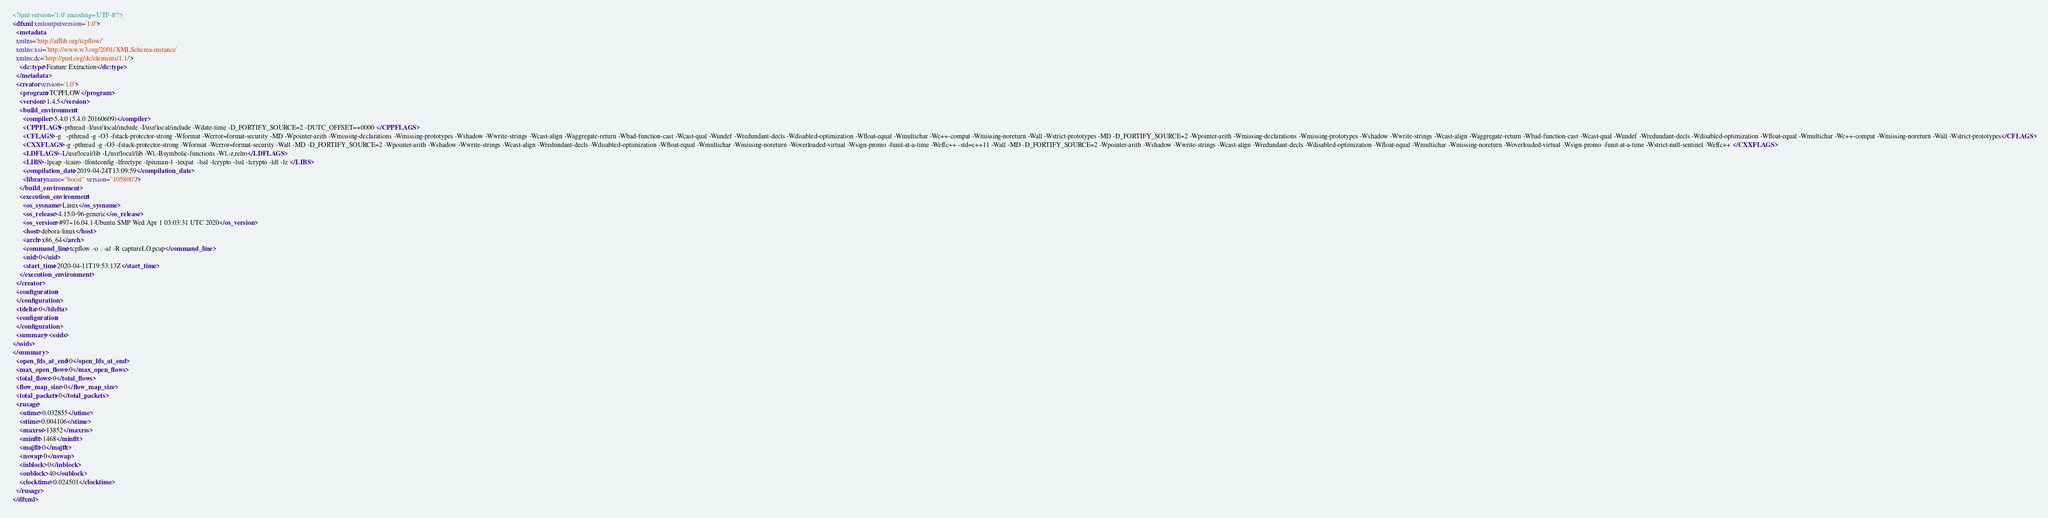Convert code to text. <code><loc_0><loc_0><loc_500><loc_500><_XML_><?xml version='1.0' encoding='UTF-8'?>
<dfxml xmloutputversion='1.0'>
  <metadata 
  xmlns='http://afflib.org/tcpflow/' 
  xmlns:xsi='http://www.w3.org/2001/XMLSchema-instance' 
  xmlns:dc='http://purl.org/dc/elements/1.1/'>
    <dc:type>Feature Extraction</dc:type>
  </metadata>
  <creator version='1.0'>
    <program>TCPFLOW</program>
    <version>1.4.5</version>
    <build_environment>
      <compiler>5.4.0 (5.4.0 20160609)</compiler>
      <CPPFLAGS>-pthread -I/usr/local/include -I/usr/local/include -Wdate-time -D_FORTIFY_SOURCE=2 -DUTC_OFFSET=+0000 </CPPFLAGS>
      <CFLAGS>-g   -pthread -g -O3 -fstack-protector-strong -Wformat -Werror=format-security -MD -Wpointer-arith -Wmissing-declarations -Wmissing-prototypes -Wshadow -Wwrite-strings -Wcast-align -Waggregate-return -Wbad-function-cast -Wcast-qual -Wundef -Wredundant-decls -Wdisabled-optimization -Wfloat-equal -Wmultichar -Wc++-compat -Wmissing-noreturn -Wall -Wstrict-prototypes -MD -D_FORTIFY_SOURCE=2 -Wpointer-arith -Wmissing-declarations -Wmissing-prototypes -Wshadow -Wwrite-strings -Wcast-align -Waggregate-return -Wbad-function-cast -Wcast-qual -Wundef -Wredundant-decls -Wdisabled-optimization -Wfloat-equal -Wmultichar -Wc++-compat -Wmissing-noreturn -Wall -Wstrict-prototypes</CFLAGS>
      <CXXFLAGS>-g -pthread -g -O3 -fstack-protector-strong -Wformat -Werror=format-security -Wall -MD -D_FORTIFY_SOURCE=2 -Wpointer-arith -Wshadow -Wwrite-strings -Wcast-align -Wredundant-decls -Wdisabled-optimization -Wfloat-equal -Wmultichar -Wmissing-noreturn -Woverloaded-virtual -Wsign-promo -funit-at-a-time -Weffc++ -std=c++11 -Wall -MD -D_FORTIFY_SOURCE=2 -Wpointer-arith -Wshadow -Wwrite-strings -Wcast-align -Wredundant-decls -Wdisabled-optimization -Wfloat-equal -Wmultichar -Wmissing-noreturn -Woverloaded-virtual -Wsign-promo -funit-at-a-time -Wstrict-null-sentinel -Weffc++ </CXXFLAGS>
      <LDFLAGS>-L/usr/local/lib -L/usr/local/lib -Wl,-Bsymbolic-functions -Wl,-z,relro</LDFLAGS>
      <LIBS>-lpcap -lcairo -lfontconfig -lfreetype -lpixman-1 -lexpat  -lssl -lcrypto -lssl -lcrypto -ldl -lz </LIBS>
      <compilation_date>2019-04-24T13:09:59</compilation_date>
      <library name="boost" version="105800"/>
    </build_environment>
    <execution_environment>
      <os_sysname>Linux</os_sysname>
      <os_release>4.15.0-96-generic</os_release>
      <os_version>#97~16.04.1-Ubuntu SMP Wed Apr 1 03:03:31 UTC 2020</os_version>
      <host>debora-linux</host>
      <arch>x86_64</arch>
      <command_line>tcpflow -o . -al -R captureLO.pcap</command_line>
      <uid>0</uid>
      <start_time>2020-04-11T19:53:13Z</start_time>
    </execution_environment>
  </creator>
  <configuration>
  </configuration>
  <tdelta>0</tdelta>
  <configuration>
  </configuration>
  <summary><ssids>
</ssids>
</summary>
  <open_fds_at_end>0</open_fds_at_end>
  <max_open_flows>0</max_open_flows>
  <total_flows>0</total_flows>
  <flow_map_size>0</flow_map_size>
  <total_packets>0</total_packets>
  <rusage>
    <utime>0.032855</utime>
    <stime>0.004106</stime>
    <maxrss>13852</maxrss>
    <minflt>1468</minflt>
    <majflt>0</majflt>
    <nswap>0</nswap>
    <inblock>0</inblock>
    <oublock>40</oublock>
    <clocktime>0.024501</clocktime>
  </rusage>
</dfxml>
</code> 